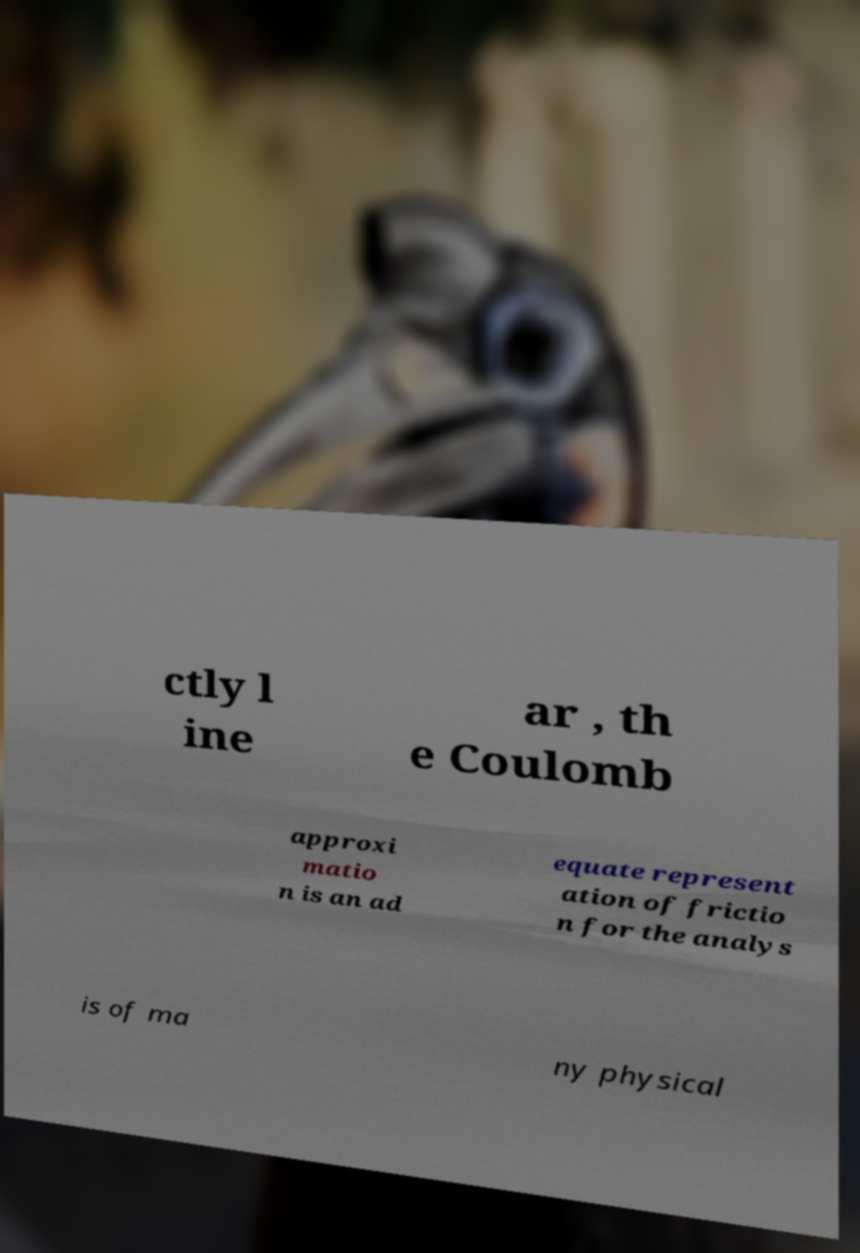Can you accurately transcribe the text from the provided image for me? ctly l ine ar , th e Coulomb approxi matio n is an ad equate represent ation of frictio n for the analys is of ma ny physical 